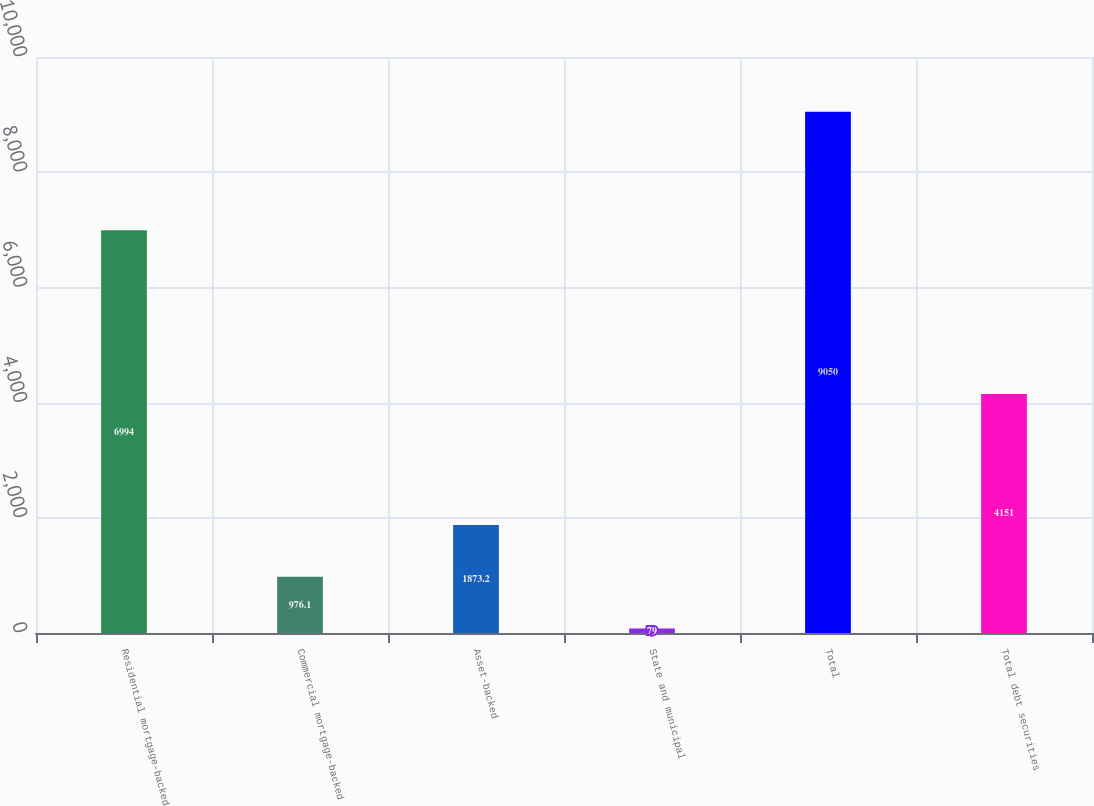Convert chart to OTSL. <chart><loc_0><loc_0><loc_500><loc_500><bar_chart><fcel>Residential mortgage-backed<fcel>Commercial mortgage-backed<fcel>Asset-backed<fcel>State and municipal<fcel>Total<fcel>Total debt securities<nl><fcel>6994<fcel>976.1<fcel>1873.2<fcel>79<fcel>9050<fcel>4151<nl></chart> 